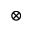<formula> <loc_0><loc_0><loc_500><loc_500>\otimes</formula> 